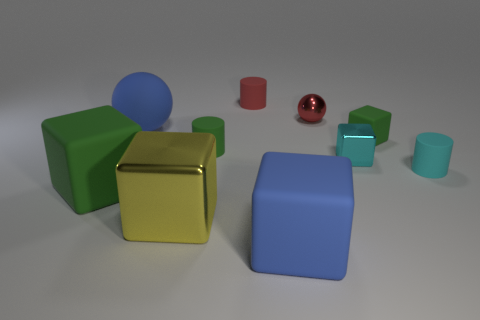Subtract all tiny green cylinders. How many cylinders are left? 2 Subtract all green cubes. How many cubes are left? 3 Subtract all spheres. How many objects are left? 8 Subtract all brown balls. Subtract all gray blocks. How many balls are left? 2 Subtract all green balls. How many brown cylinders are left? 0 Subtract all small cyan cylinders. Subtract all tiny cyan cubes. How many objects are left? 8 Add 1 yellow cubes. How many yellow cubes are left? 2 Add 6 cyan objects. How many cyan objects exist? 8 Subtract 0 cyan spheres. How many objects are left? 10 Subtract 2 spheres. How many spheres are left? 0 